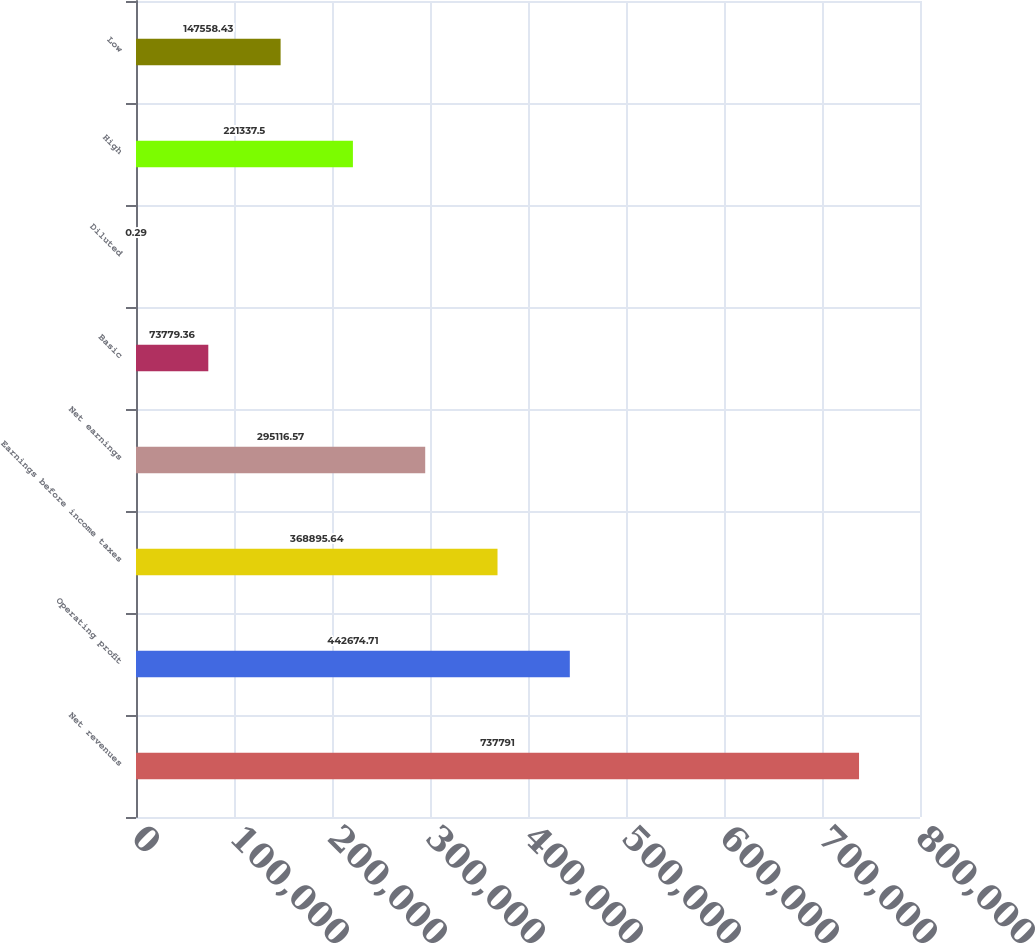Convert chart. <chart><loc_0><loc_0><loc_500><loc_500><bar_chart><fcel>Net revenues<fcel>Operating profit<fcel>Earnings before income taxes<fcel>Net earnings<fcel>Basic<fcel>Diluted<fcel>High<fcel>Low<nl><fcel>737791<fcel>442675<fcel>368896<fcel>295117<fcel>73779.4<fcel>0.29<fcel>221338<fcel>147558<nl></chart> 